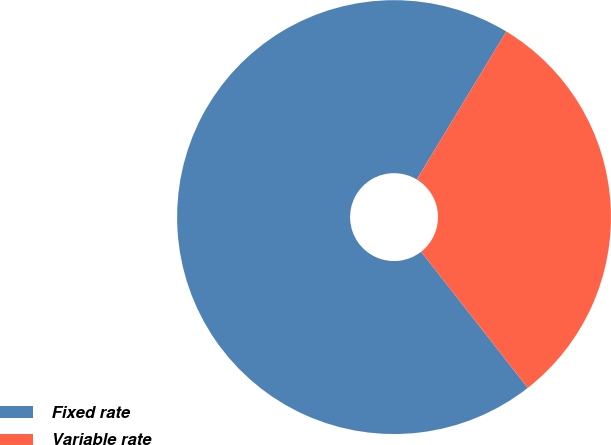Convert chart. <chart><loc_0><loc_0><loc_500><loc_500><pie_chart><fcel>Fixed rate<fcel>Variable rate<nl><fcel>69.23%<fcel>30.77%<nl></chart> 